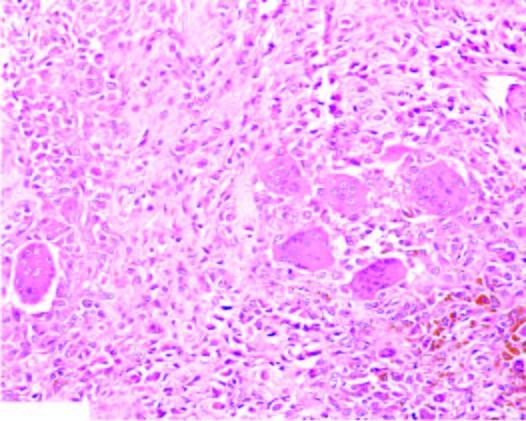what shows infiltrate of small oval to spindled histiocytes with numerous interspersed multinucleate giant cells lyning in a background of fibrous tissue?
Answer the question using a single word or phrase. Tumour 